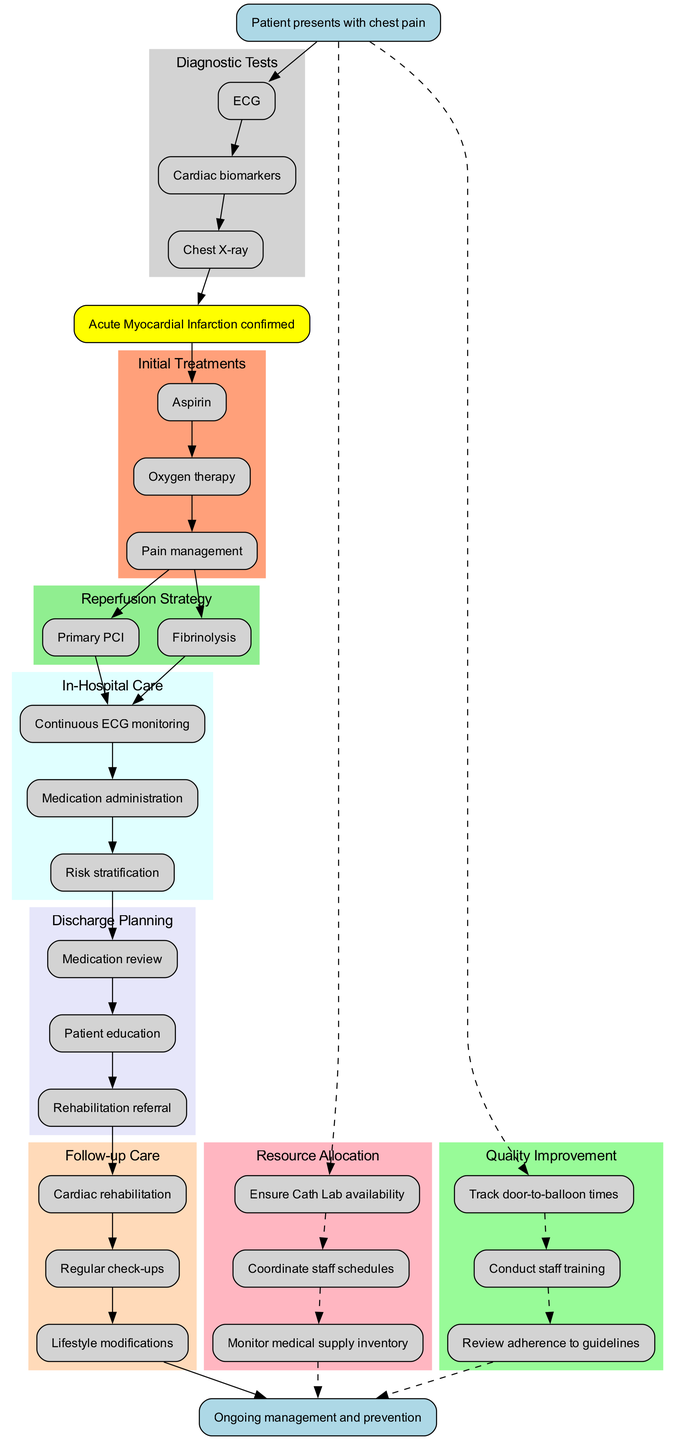What is the first diagnostic test indicated in the pathway? The diagram shows that after the patient presents with chest pain, the first node represents the ECG, which is the first diagnostic test indicated in the pathway.
Answer: ECG How many initial treatments are listed in the pathway? The diagram lists three initial treatments following the diagnosis of acute myocardial infarction, specifically Aspirin, Oxygen therapy, and Pain management. Counting these gives a total of three initial treatments.
Answer: 3 What are the two options for the reperfusion strategy? The diagram clearly lists two options labeled as Primary PCI and Fibrinolysis under the Reperfusion Strategy section.
Answer: Primary PCI, Fibrinolysis What is the last step in the follow-up care? Following the sequence in the diagram, the last step listed under Follow-up Care is Lifestyle modifications, indicating it is the final action in this care phase.
Answer: Lifestyle modifications How does the quality improvement process relate to the initial presentation? The diagram indicates a dashed line connecting the resource allocation and quality improvement sections back to the start. This suggests that both components are ongoing aspects tied to the initial presentation and management of the patient's condition.
Answer: Ongoing Which phase follows continuous ECG monitoring during in-hospital care? The in-hospital care section of the diagram shows that after continuous ECG monitoring, the medication administration phase follows immediately in the pathway.
Answer: Medication administration What type of education is provided during discharge planning? The diagram specifies that Patient education is listed in the discharge planning section, indicating the type of education provided to the patient prior to discharge.
Answer: Patient education What role does staff coordination play in resource allocation? Within the diagram, one of the key actions listed under resource allocation is "Coordinate staff schedules," highlighting the importance of staff coordination in ensuring that resources are adequately managed.
Answer: Coordinate staff schedules How are lifestyle modifications emphasized in the diagram? The follow-up care section emphasizes Lifestyle modifications as a distinct node, underscoring its importance in the ongoing management and prevention strategy after the initial treatment of acute myocardial infarction.
Answer: Emphasized 